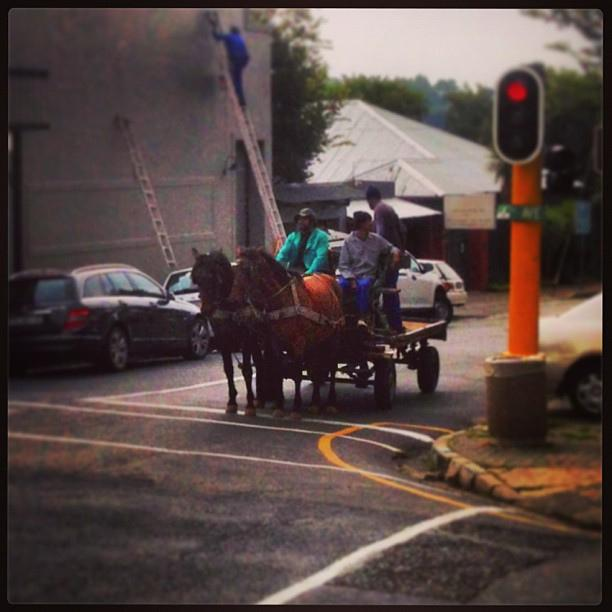What color is the big horse to the right with the flat cart behind it?

Choices:
A) chestnut
B) white
C) black
D) yellow chestnut 